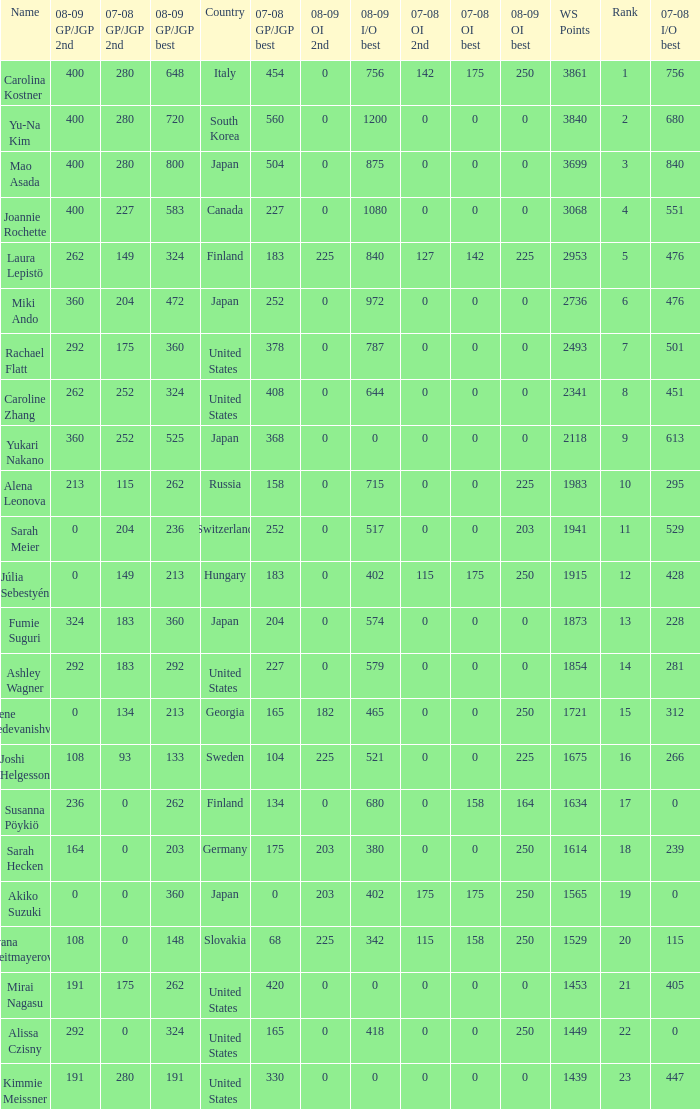08-09 gp/jgp 2nd is 213 and ws points will be what maximum 1983.0. 